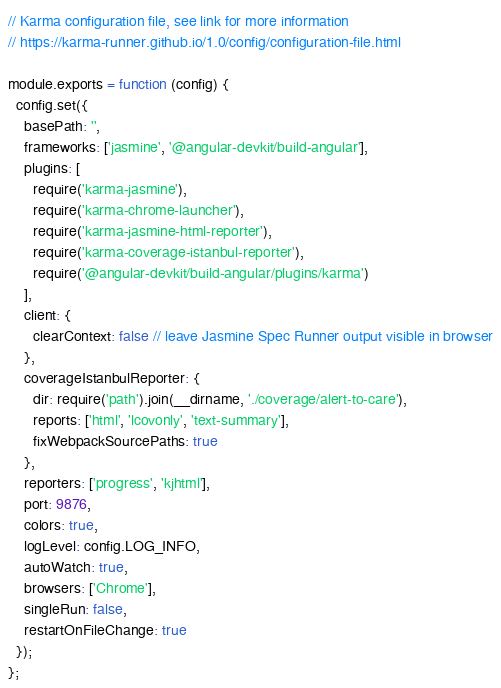<code> <loc_0><loc_0><loc_500><loc_500><_JavaScript_>// Karma configuration file, see link for more information
// https://karma-runner.github.io/1.0/config/configuration-file.html

module.exports = function (config) {
  config.set({
    basePath: '',
    frameworks: ['jasmine', '@angular-devkit/build-angular'],
    plugins: [
      require('karma-jasmine'),
      require('karma-chrome-launcher'),
      require('karma-jasmine-html-reporter'),
      require('karma-coverage-istanbul-reporter'),
      require('@angular-devkit/build-angular/plugins/karma')
    ],
    client: {
      clearContext: false // leave Jasmine Spec Runner output visible in browser
    },
    coverageIstanbulReporter: {
      dir: require('path').join(__dirname, './coverage/alert-to-care'),
      reports: ['html', 'lcovonly', 'text-summary'],
      fixWebpackSourcePaths: true
    },
    reporters: ['progress', 'kjhtml'],
    port: 9876,
    colors: true,
    logLevel: config.LOG_INFO,
    autoWatch: true,
    browsers: ['Chrome'],
    singleRun: false,
    restartOnFileChange: true
  });
};
</code> 